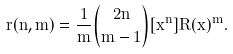<formula> <loc_0><loc_0><loc_500><loc_500>r ( n , m ) = \frac { 1 } { m } { 2 n \choose m - 1 } [ x ^ { n } ] R ( x ) ^ { m } .</formula> 